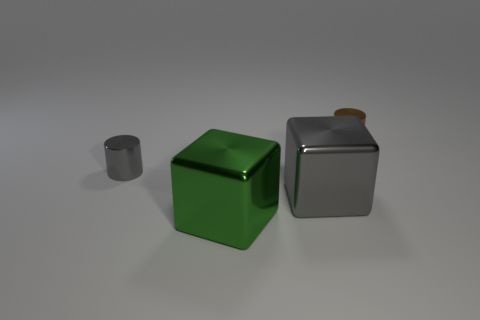Subtract all gray cylinders. How many cylinders are left? 1 Subtract 0 cyan cylinders. How many objects are left? 4 Subtract 1 cylinders. How many cylinders are left? 1 Subtract all gray cubes. Subtract all red spheres. How many cubes are left? 1 Subtract all red cubes. How many gray cylinders are left? 1 Subtract all cyan metallic blocks. Subtract all green shiny cubes. How many objects are left? 3 Add 1 big green objects. How many big green objects are left? 2 Add 1 big brown rubber objects. How many big brown rubber objects exist? 1 Add 3 small metallic objects. How many objects exist? 7 